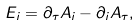<formula> <loc_0><loc_0><loc_500><loc_500>E _ { i } = \partial _ { \tau } A _ { i } - \partial _ { i } A _ { \tau } ,</formula> 